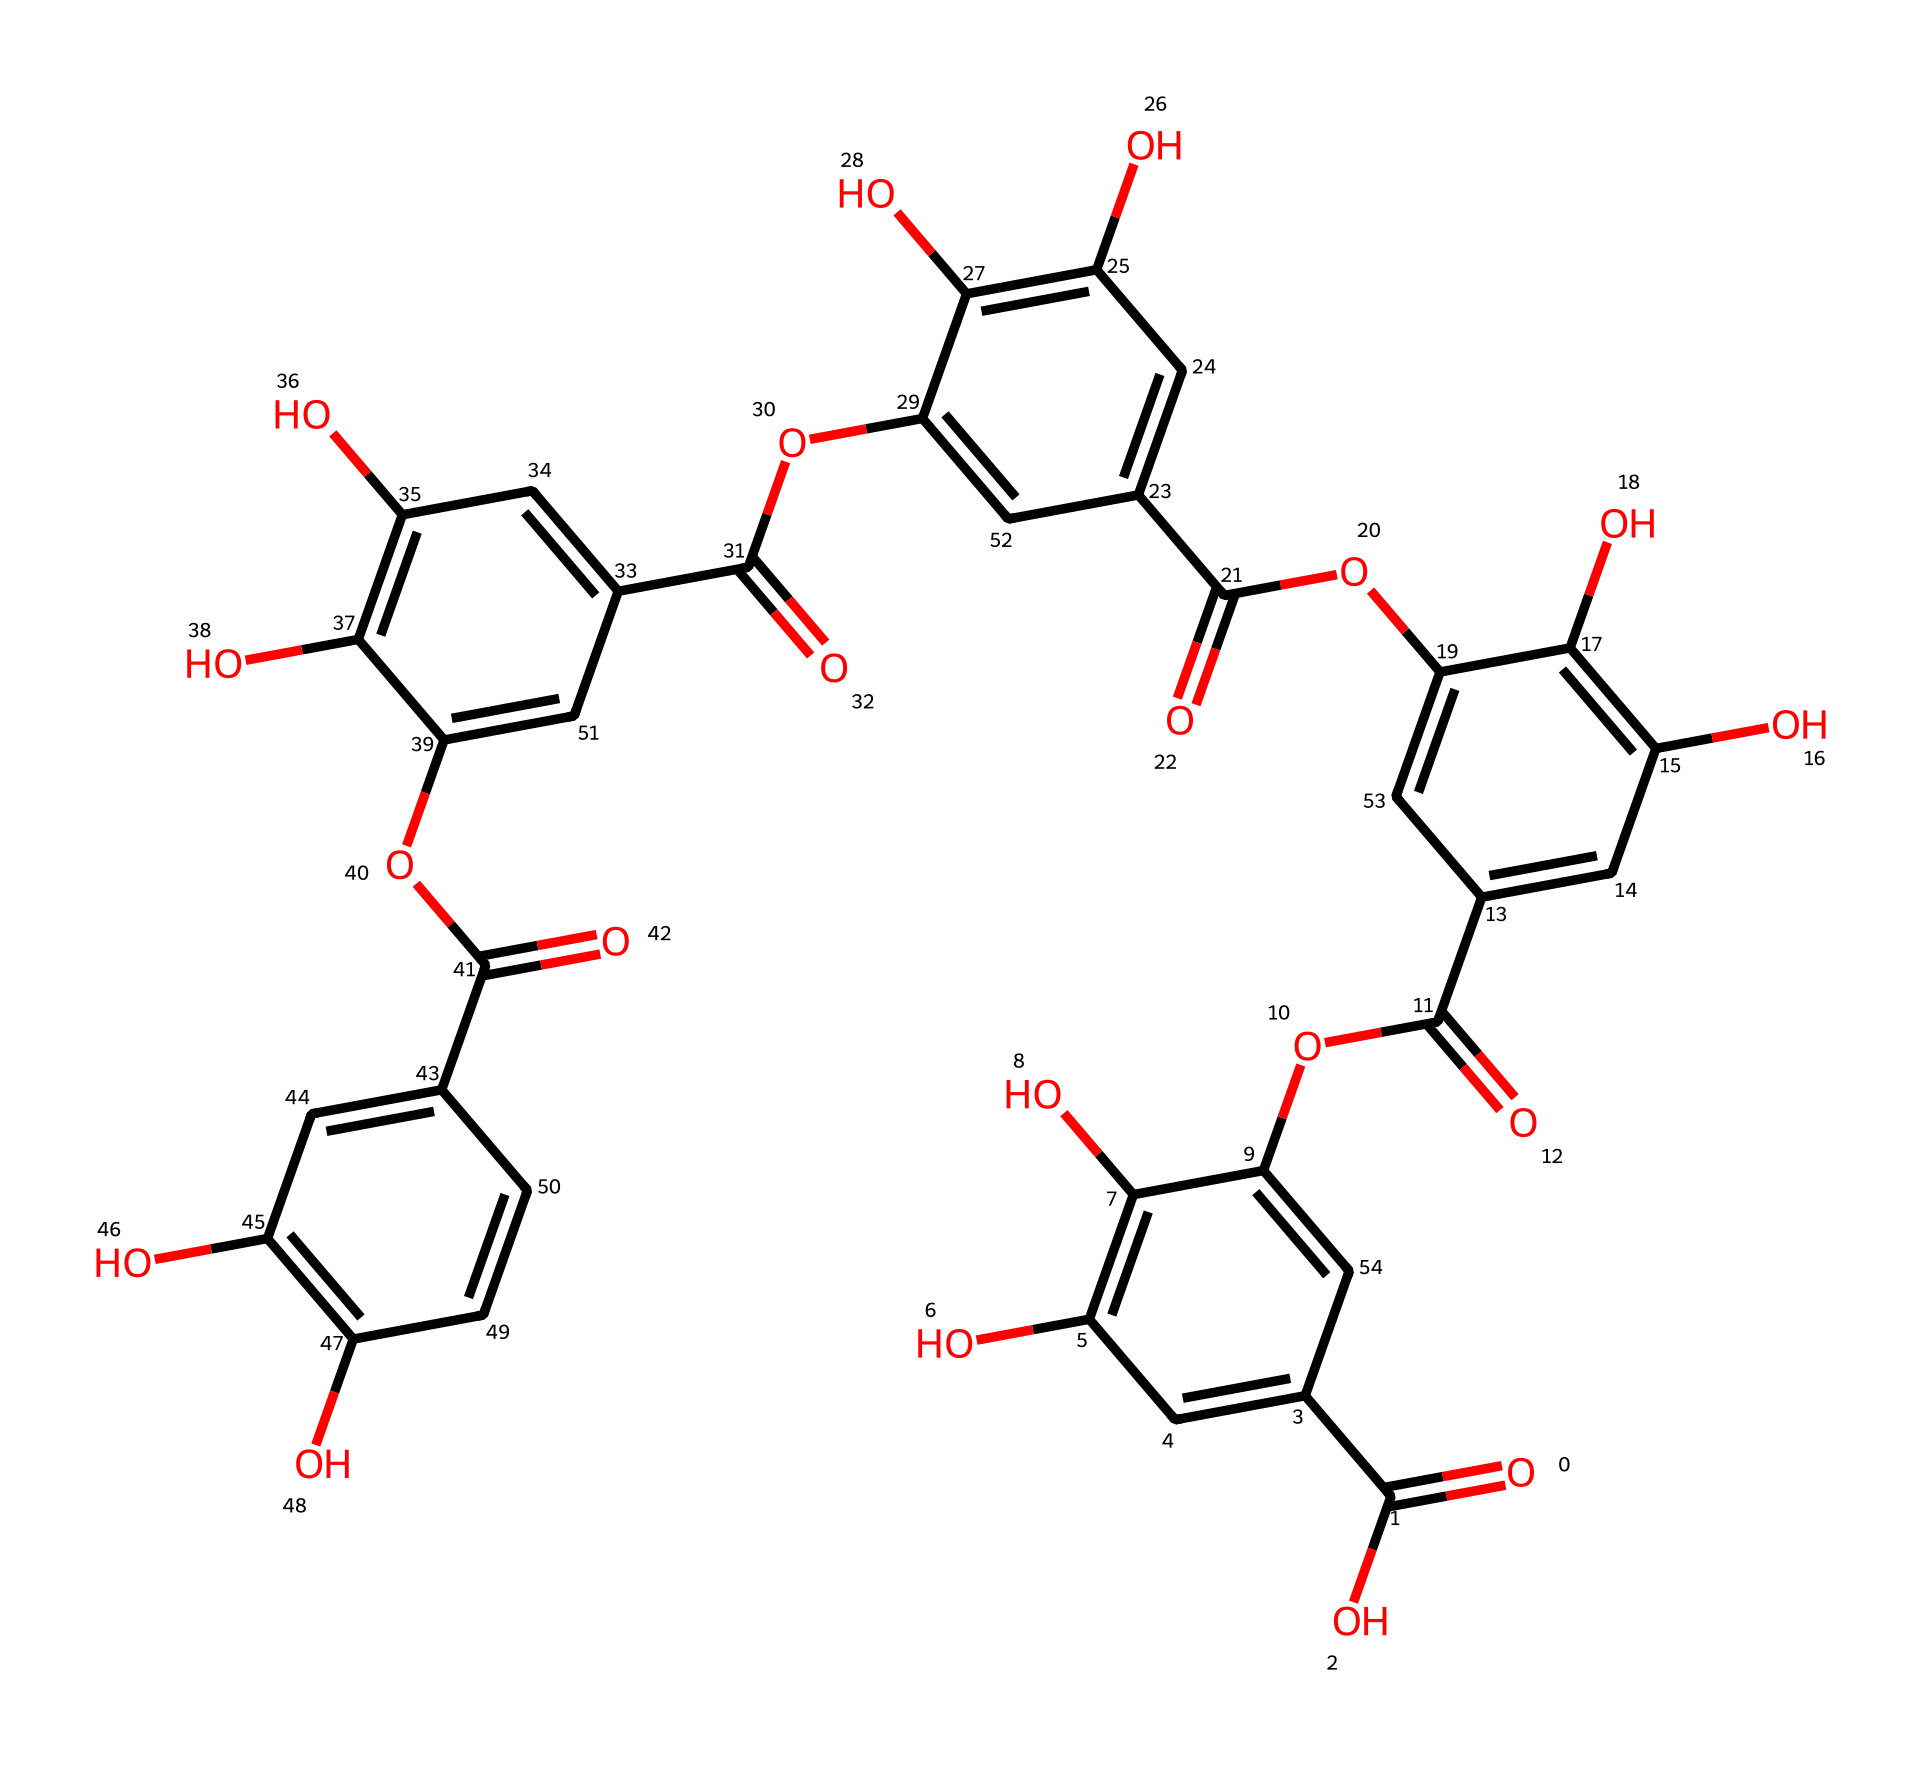What is the chemical name of the compound represented by this SMILES? The given SMILES corresponds to a polyphenolic compound commonly known as tannic acid, which is found in tea. When interpreted through its structure, it reveals the presence of multiple phenolic hydroxyl groups.
Answer: tannic acid How many carbon atoms are present in tannic acid? By analyzing the SMILES, you can count the number of carbon atoms represented. Each 'C' in the SMILES, as well as any additional carbon implied in the cyclic or branched structures, leads to a total of 35 carbon atoms.
Answer: 35 What type of acid is tannic acid? Tannic acid is classified as a polyphenolic acid, which means it has multiple phenolic structures in its molecular framework that contribute to its acidic properties.
Answer: polyphenolic acid How many carboxylic acid groups are in tannic acid? By identifying the carboxylic acid functional groups (–COOH) in the SMILES structure, you can see there are 5 carboxylic acid groups indicating the molecule's acidic nature.
Answer: 5 What feature in the chemical structure gives tannic acid its astringent taste? The astringent taste is primarily attributed to the presence of multiple hydroxyl groups (–OH) and the phenolic structure, which contribute to the interaction with proteins, causing the sensation of dryness in the mouth.
Answer: hydroxyl groups What is the overall charge of tannic acid at physiological pH? At physiological pH, the carboxylic acid groups in tannic acid would primarily dissociate, leading to a net negative charge due to the ionization of its acidic protons.
Answer: negative charge 